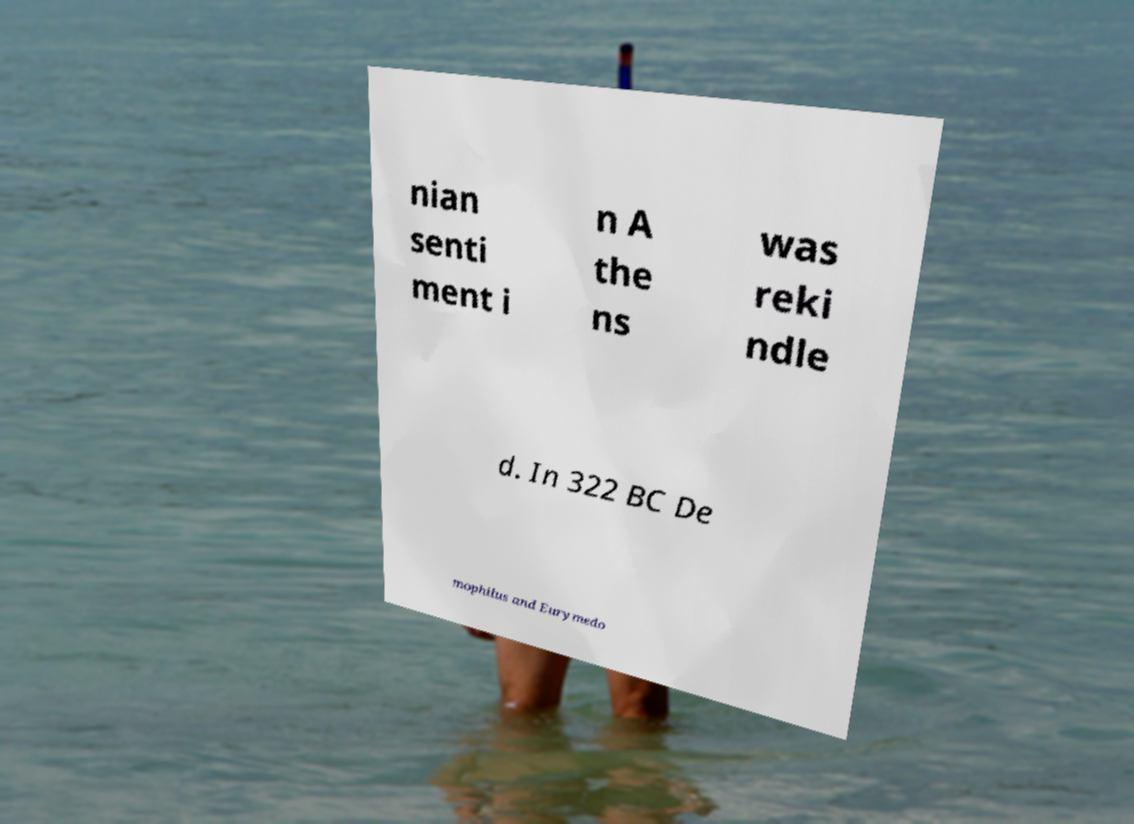I need the written content from this picture converted into text. Can you do that? nian senti ment i n A the ns was reki ndle d. In 322 BC De mophilus and Eurymedo 